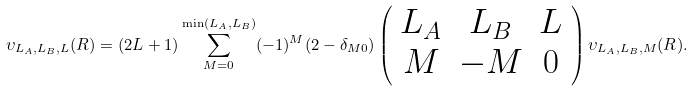<formula> <loc_0><loc_0><loc_500><loc_500>\upsilon _ { L _ { A } , L _ { B } , L } ( R ) = ( 2 L + 1 ) \sum _ { M = 0 } ^ { \min ( L _ { A } , L _ { B } ) } ( - 1 ) ^ { M } ( 2 - \delta _ { M 0 } ) \left ( \begin{array} { c c c } L _ { A } & L _ { B } & L \\ M & - M & 0 \end{array} \right ) \upsilon _ { L _ { A } , L _ { B } , M } ( R ) .</formula> 